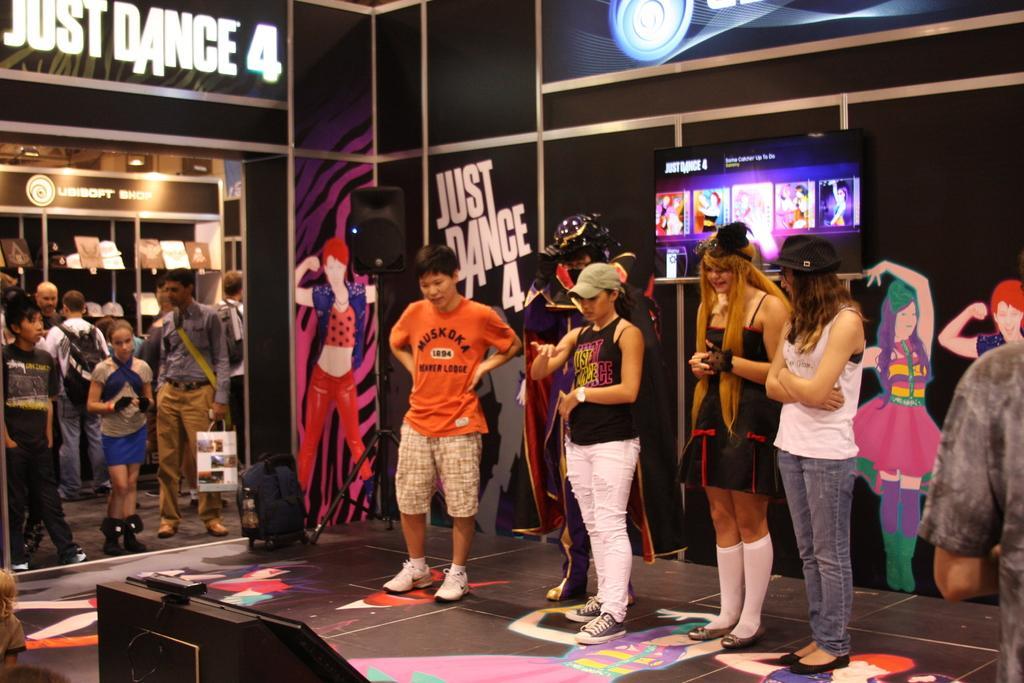Describe this image in one or two sentences. There are people standing in the foreground area of the image, there are posters on the wall, other people and objects in the background. 